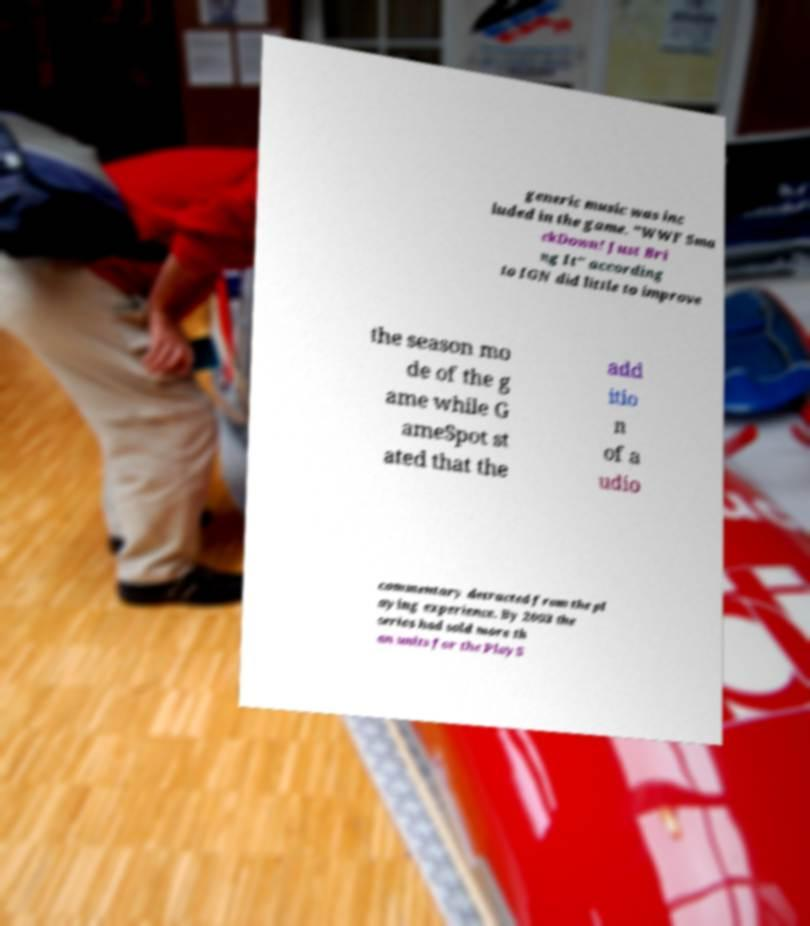Please identify and transcribe the text found in this image. generic music was inc luded in the game. "WWF Sma ckDown! Just Bri ng It" according to IGN did little to improve the season mo de of the g ame while G ameSpot st ated that the add itio n of a udio commentary detracted from the pl aying experience. By 2003 the series had sold more th an units for the PlayS 